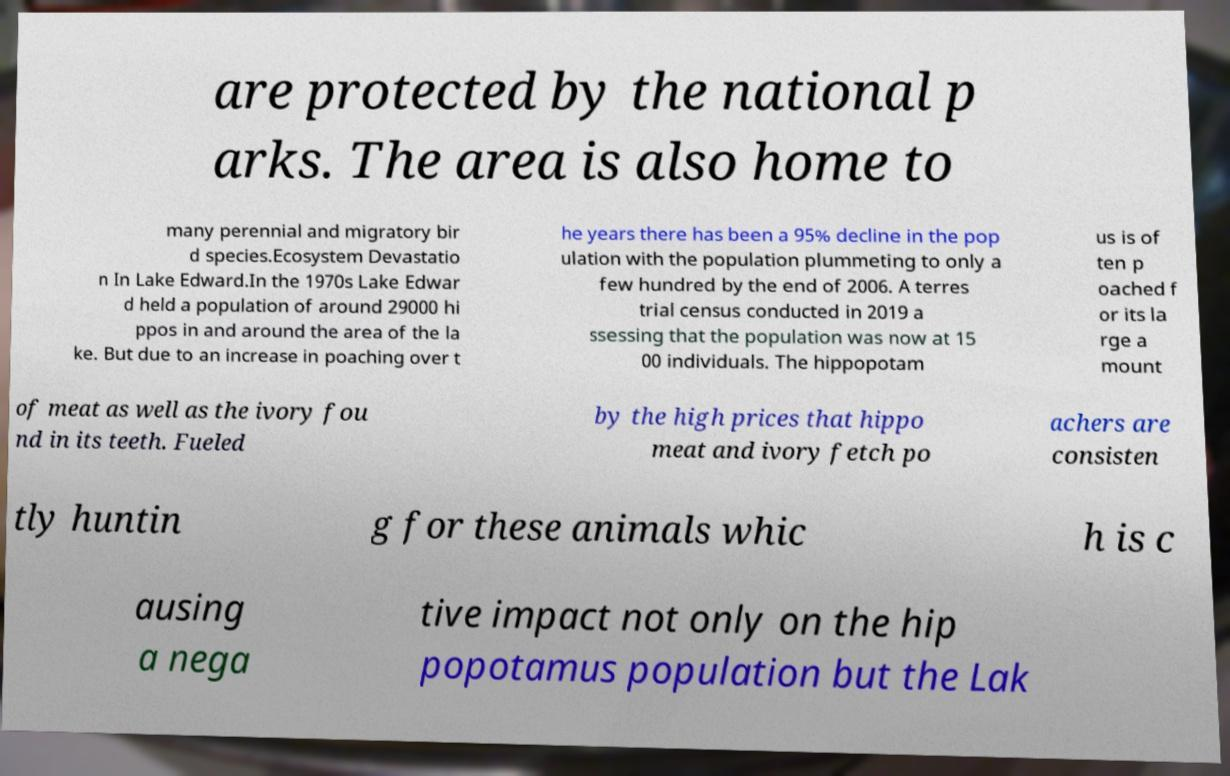Can you read and provide the text displayed in the image?This photo seems to have some interesting text. Can you extract and type it out for me? are protected by the national p arks. The area is also home to many perennial and migratory bir d species.Ecosystem Devastatio n In Lake Edward.In the 1970s Lake Edwar d held a population of around 29000 hi ppos in and around the area of the la ke. But due to an increase in poaching over t he years there has been a 95% decline in the pop ulation with the population plummeting to only a few hundred by the end of 2006. A terres trial census conducted in 2019 a ssessing that the population was now at 15 00 individuals. The hippopotam us is of ten p oached f or its la rge a mount of meat as well as the ivory fou nd in its teeth. Fueled by the high prices that hippo meat and ivory fetch po achers are consisten tly huntin g for these animals whic h is c ausing a nega tive impact not only on the hip popotamus population but the Lak 